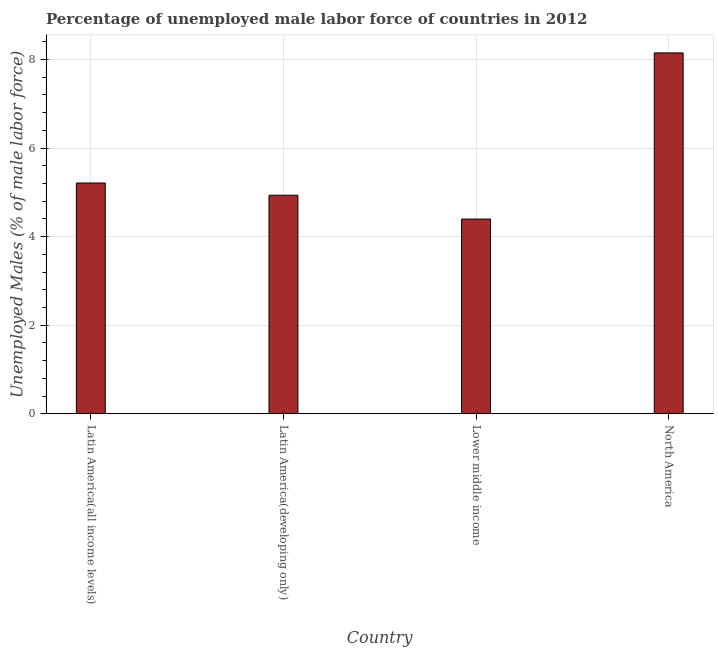Does the graph contain any zero values?
Your response must be concise. No. What is the title of the graph?
Your answer should be very brief. Percentage of unemployed male labor force of countries in 2012. What is the label or title of the Y-axis?
Offer a terse response. Unemployed Males (% of male labor force). What is the total unemployed male labour force in Latin America(all income levels)?
Offer a terse response. 5.21. Across all countries, what is the maximum total unemployed male labour force?
Your answer should be compact. 8.15. Across all countries, what is the minimum total unemployed male labour force?
Give a very brief answer. 4.4. In which country was the total unemployed male labour force maximum?
Your response must be concise. North America. In which country was the total unemployed male labour force minimum?
Provide a succinct answer. Lower middle income. What is the sum of the total unemployed male labour force?
Make the answer very short. 22.69. What is the difference between the total unemployed male labour force in Latin America(developing only) and Lower middle income?
Your response must be concise. 0.54. What is the average total unemployed male labour force per country?
Provide a succinct answer. 5.67. What is the median total unemployed male labour force?
Provide a short and direct response. 5.07. In how many countries, is the total unemployed male labour force greater than 7.6 %?
Ensure brevity in your answer.  1. What is the ratio of the total unemployed male labour force in Latin America(all income levels) to that in Lower middle income?
Ensure brevity in your answer.  1.19. Is the difference between the total unemployed male labour force in Latin America(developing only) and Lower middle income greater than the difference between any two countries?
Give a very brief answer. No. What is the difference between the highest and the second highest total unemployed male labour force?
Offer a very short reply. 2.94. What is the difference between the highest and the lowest total unemployed male labour force?
Ensure brevity in your answer.  3.75. How many bars are there?
Make the answer very short. 4. Are all the bars in the graph horizontal?
Ensure brevity in your answer.  No. How many countries are there in the graph?
Provide a short and direct response. 4. What is the Unemployed Males (% of male labor force) of Latin America(all income levels)?
Give a very brief answer. 5.21. What is the Unemployed Males (% of male labor force) of Latin America(developing only)?
Offer a very short reply. 4.93. What is the Unemployed Males (% of male labor force) in Lower middle income?
Make the answer very short. 4.4. What is the Unemployed Males (% of male labor force) in North America?
Give a very brief answer. 8.15. What is the difference between the Unemployed Males (% of male labor force) in Latin America(all income levels) and Latin America(developing only)?
Make the answer very short. 0.28. What is the difference between the Unemployed Males (% of male labor force) in Latin America(all income levels) and Lower middle income?
Make the answer very short. 0.81. What is the difference between the Unemployed Males (% of male labor force) in Latin America(all income levels) and North America?
Offer a very short reply. -2.94. What is the difference between the Unemployed Males (% of male labor force) in Latin America(developing only) and Lower middle income?
Offer a terse response. 0.54. What is the difference between the Unemployed Males (% of male labor force) in Latin America(developing only) and North America?
Make the answer very short. -3.21. What is the difference between the Unemployed Males (% of male labor force) in Lower middle income and North America?
Keep it short and to the point. -3.75. What is the ratio of the Unemployed Males (% of male labor force) in Latin America(all income levels) to that in Latin America(developing only)?
Keep it short and to the point. 1.06. What is the ratio of the Unemployed Males (% of male labor force) in Latin America(all income levels) to that in Lower middle income?
Offer a very short reply. 1.19. What is the ratio of the Unemployed Males (% of male labor force) in Latin America(all income levels) to that in North America?
Give a very brief answer. 0.64. What is the ratio of the Unemployed Males (% of male labor force) in Latin America(developing only) to that in Lower middle income?
Provide a short and direct response. 1.12. What is the ratio of the Unemployed Males (% of male labor force) in Latin America(developing only) to that in North America?
Offer a very short reply. 0.61. What is the ratio of the Unemployed Males (% of male labor force) in Lower middle income to that in North America?
Your answer should be very brief. 0.54. 